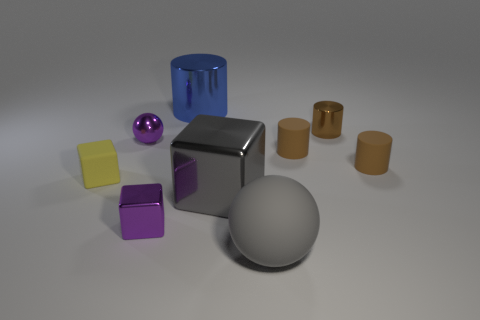Is there a big shiny cylinder of the same color as the small sphere?
Your response must be concise. No. There is a small ball that is the same color as the small metallic block; what is its material?
Ensure brevity in your answer.  Metal. What number of small metallic spheres are the same color as the big cylinder?
Your response must be concise. 0. How many things are tiny purple spheres on the right side of the small yellow rubber cube or brown rubber cylinders?
Make the answer very short. 3. The tiny cylinder that is the same material as the small purple block is what color?
Your response must be concise. Brown. Is there a brown shiny object that has the same size as the gray ball?
Your answer should be compact. No. What number of objects are tiny metallic objects on the left side of the big gray shiny object or small metallic objects that are to the right of the big matte ball?
Give a very brief answer. 3. What shape is the blue thing that is the same size as the gray shiny thing?
Your response must be concise. Cylinder. Is there another thing that has the same shape as the yellow object?
Provide a short and direct response. Yes. Are there fewer big blue cylinders than shiny cubes?
Give a very brief answer. Yes. 